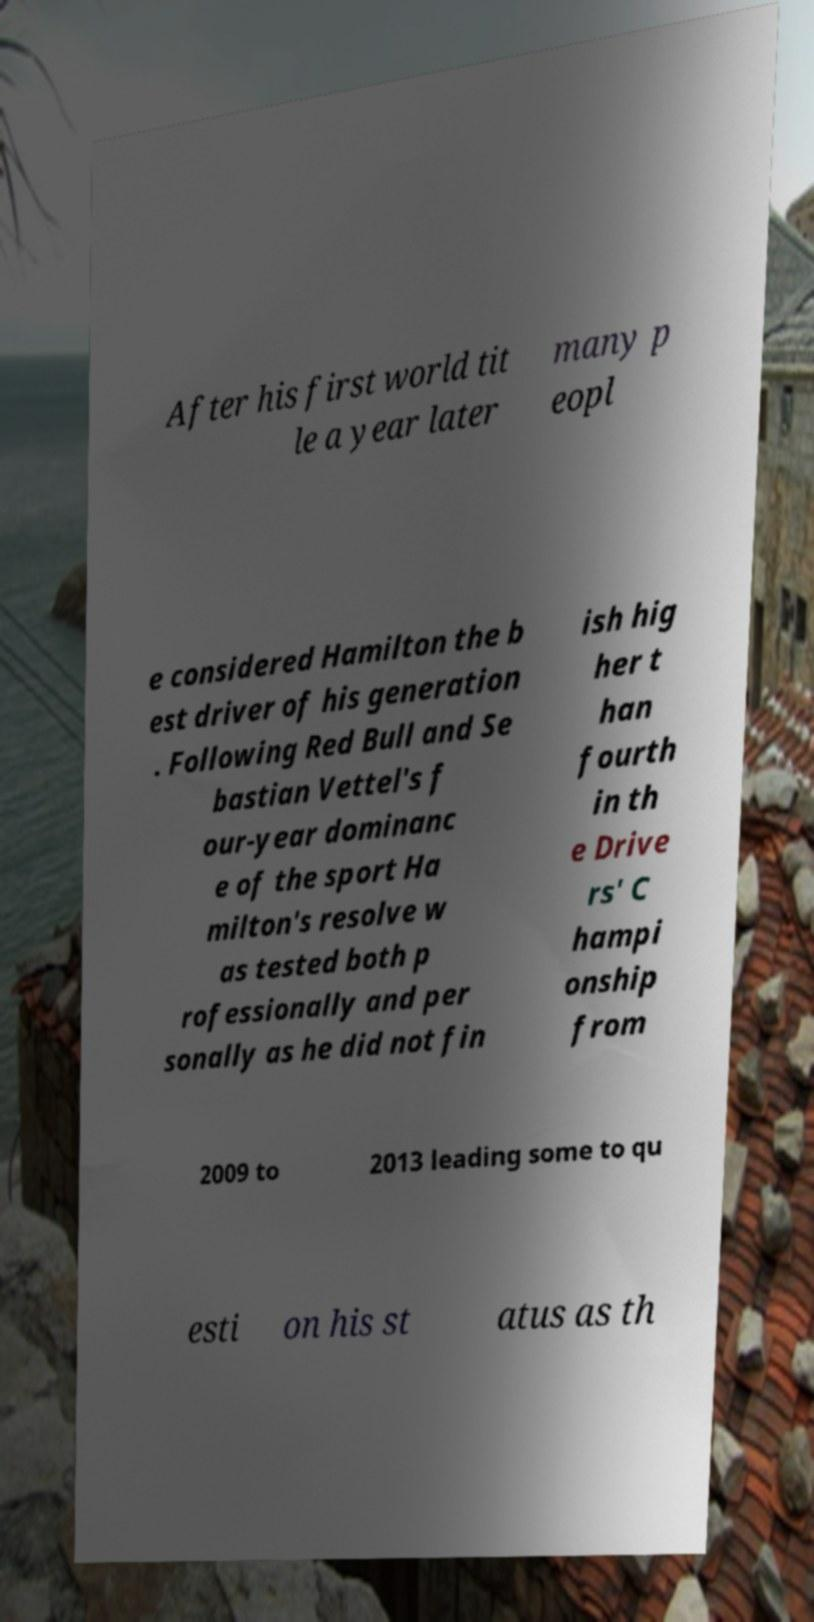There's text embedded in this image that I need extracted. Can you transcribe it verbatim? After his first world tit le a year later many p eopl e considered Hamilton the b est driver of his generation . Following Red Bull and Se bastian Vettel's f our-year dominanc e of the sport Ha milton's resolve w as tested both p rofessionally and per sonally as he did not fin ish hig her t han fourth in th e Drive rs' C hampi onship from 2009 to 2013 leading some to qu esti on his st atus as th 